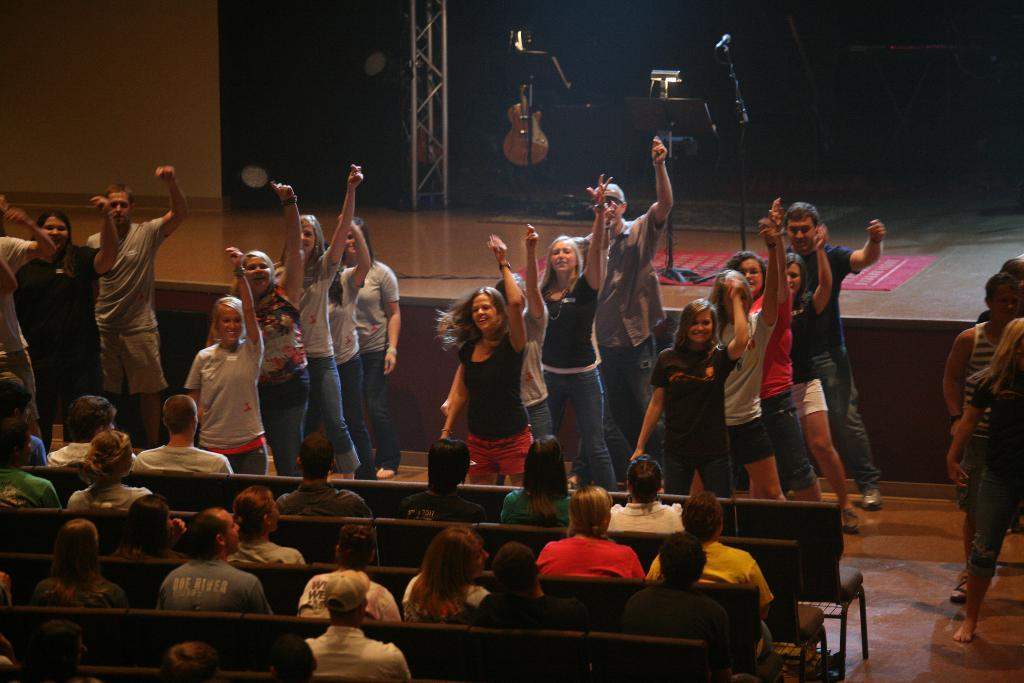What are the people in the image doing? There are people sitting on chairs in the image, and some people are dancing in the background. What can be seen on the stage in the image? Musical instruments are present on the stage. What is the purpose of the chairs in the image? The chairs are likely for the people to sit on while watching the performance. What is the background of the image? There is a wall visible in the image. How many brothers are performing on the stage in the image? There is no mention of brothers in the image, nor is there any indication that the performers are related. What type of light is being used to illuminate the stage in the image? There is no information about the lighting on the stage in the image. 